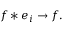<formula> <loc_0><loc_0><loc_500><loc_500>f * e _ { i } \to f .</formula> 